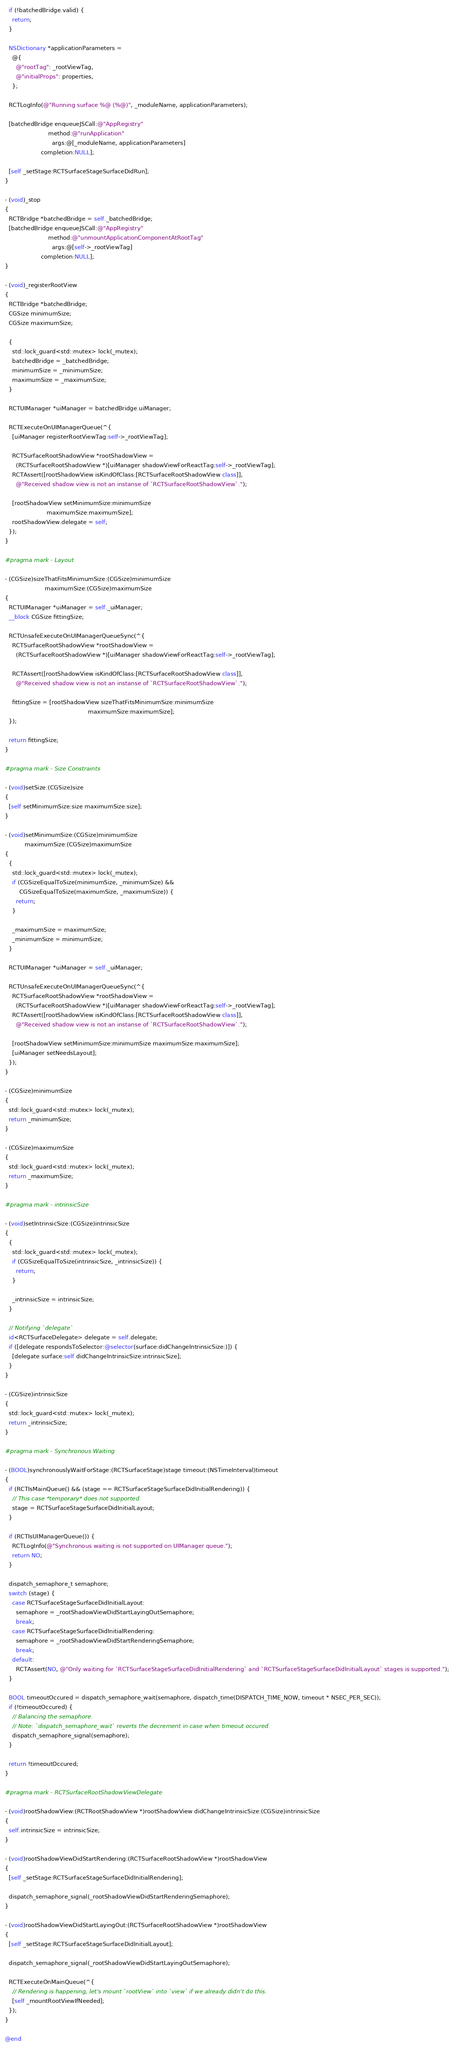<code> <loc_0><loc_0><loc_500><loc_500><_ObjectiveC_>  if (!batchedBridge.valid) {
    return;
  }

  NSDictionary *applicationParameters =
    @{
      @"rootTag": _rootViewTag,
      @"initialProps": properties,
    };

  RCTLogInfo(@"Running surface %@ (%@)", _moduleName, applicationParameters);

  [batchedBridge enqueueJSCall:@"AppRegistry"
                        method:@"runApplication"
                          args:@[_moduleName, applicationParameters]
                    completion:NULL];

  [self _setStage:RCTSurfaceStageSurfaceDidRun];
}

- (void)_stop
{
  RCTBridge *batchedBridge = self._batchedBridge;
  [batchedBridge enqueueJSCall:@"AppRegistry"
                        method:@"unmountApplicationComponentAtRootTag"
                          args:@[self->_rootViewTag]
                    completion:NULL];
}

- (void)_registerRootView
{
  RCTBridge *batchedBridge;
  CGSize minimumSize;
  CGSize maximumSize;

  {
    std::lock_guard<std::mutex> lock(_mutex);
    batchedBridge = _batchedBridge;
    minimumSize = _minimumSize;
    maximumSize = _maximumSize;
  }

  RCTUIManager *uiManager = batchedBridge.uiManager;

  RCTExecuteOnUIManagerQueue(^{
    [uiManager registerRootViewTag:self->_rootViewTag];

    RCTSurfaceRootShadowView *rootShadowView =
      (RCTSurfaceRootShadowView *)[uiManager shadowViewForReactTag:self->_rootViewTag];
    RCTAssert([rootShadowView isKindOfClass:[RCTSurfaceRootShadowView class]],
      @"Received shadow view is not an instanse of `RCTSurfaceRootShadowView`.");

    [rootShadowView setMinimumSize:minimumSize
                       maximumSize:maximumSize];
    rootShadowView.delegate = self;
  });
}

#pragma mark - Layout

- (CGSize)sizeThatFitsMinimumSize:(CGSize)minimumSize
                      maximumSize:(CGSize)maximumSize
{
  RCTUIManager *uiManager = self._uiManager;
  __block CGSize fittingSize;

  RCTUnsafeExecuteOnUIManagerQueueSync(^{
    RCTSurfaceRootShadowView *rootShadowView =
      (RCTSurfaceRootShadowView *)[uiManager shadowViewForReactTag:self->_rootViewTag];

    RCTAssert([rootShadowView isKindOfClass:[RCTSurfaceRootShadowView class]],
      @"Received shadow view is not an instanse of `RCTSurfaceRootShadowView`.");

    fittingSize = [rootShadowView sizeThatFitsMinimumSize:minimumSize
                                              maximumSize:maximumSize];
  });

  return fittingSize;
}

#pragma mark - Size Constraints

- (void)setSize:(CGSize)size
{
  [self setMinimumSize:size maximumSize:size];
}

- (void)setMinimumSize:(CGSize)minimumSize
           maximumSize:(CGSize)maximumSize
{
  {
    std::lock_guard<std::mutex> lock(_mutex);
    if (CGSizeEqualToSize(minimumSize, _minimumSize) &&
        CGSizeEqualToSize(maximumSize, _maximumSize)) {
      return;
    }

    _maximumSize = maximumSize;
    _minimumSize = minimumSize;
  }

  RCTUIManager *uiManager = self._uiManager;

  RCTUnsafeExecuteOnUIManagerQueueSync(^{
    RCTSurfaceRootShadowView *rootShadowView =
      (RCTSurfaceRootShadowView *)[uiManager shadowViewForReactTag:self->_rootViewTag];
    RCTAssert([rootShadowView isKindOfClass:[RCTSurfaceRootShadowView class]],
      @"Received shadow view is not an instanse of `RCTSurfaceRootShadowView`.");

    [rootShadowView setMinimumSize:minimumSize maximumSize:maximumSize];
    [uiManager setNeedsLayout];
  });
}

- (CGSize)minimumSize
{
  std::lock_guard<std::mutex> lock(_mutex);
  return _minimumSize;
}

- (CGSize)maximumSize
{
  std::lock_guard<std::mutex> lock(_mutex);
  return _maximumSize;
}

#pragma mark - intrinsicSize

- (void)setIntrinsicSize:(CGSize)intrinsicSize
{
  {
    std::lock_guard<std::mutex> lock(_mutex);
    if (CGSizeEqualToSize(intrinsicSize, _intrinsicSize)) {
      return;
    }

    _intrinsicSize = intrinsicSize;
  }

  // Notifying `delegate`
  id<RCTSurfaceDelegate> delegate = self.delegate;
  if ([delegate respondsToSelector:@selector(surface:didChangeIntrinsicSize:)]) {
    [delegate surface:self didChangeIntrinsicSize:intrinsicSize];
  }
}

- (CGSize)intrinsicSize
{
  std::lock_guard<std::mutex> lock(_mutex);
  return _intrinsicSize;
}

#pragma mark - Synchronous Waiting

- (BOOL)synchronouslyWaitForStage:(RCTSurfaceStage)stage timeout:(NSTimeInterval)timeout
{
  if (RCTIsMainQueue() && (stage == RCTSurfaceStageSurfaceDidInitialRendering)) {
    // This case *temporary* does not supported.
    stage = RCTSurfaceStageSurfaceDidInitialLayout;
  }

  if (RCTIsUIManagerQueue()) {
    RCTLogInfo(@"Synchronous waiting is not supported on UIManager queue.");
    return NO;
  }

  dispatch_semaphore_t semaphore;
  switch (stage) {
    case RCTSurfaceStageSurfaceDidInitialLayout:
      semaphore = _rootShadowViewDidStartLayingOutSemaphore;
      break;
    case RCTSurfaceStageSurfaceDidInitialRendering:
      semaphore = _rootShadowViewDidStartRenderingSemaphore;
      break;
    default:
      RCTAssert(NO, @"Only waiting for `RCTSurfaceStageSurfaceDidInitialRendering` and `RCTSurfaceStageSurfaceDidInitialLayout` stages is supported.");
  }

  BOOL timeoutOccured = dispatch_semaphore_wait(semaphore, dispatch_time(DISPATCH_TIME_NOW, timeout * NSEC_PER_SEC));
  if (!timeoutOccured) {
    // Balancing the semaphore.
    // Note: `dispatch_semaphore_wait` reverts the decrement in case when timeout occured.
    dispatch_semaphore_signal(semaphore);
  }

  return !timeoutOccured;
}

#pragma mark - RCTSurfaceRootShadowViewDelegate

- (void)rootShadowView:(RCTRootShadowView *)rootShadowView didChangeIntrinsicSize:(CGSize)intrinsicSize
{
  self.intrinsicSize = intrinsicSize;
}

- (void)rootShadowViewDidStartRendering:(RCTSurfaceRootShadowView *)rootShadowView
{
  [self _setStage:RCTSurfaceStageSurfaceDidInitialRendering];

  dispatch_semaphore_signal(_rootShadowViewDidStartRenderingSemaphore);
}

- (void)rootShadowViewDidStartLayingOut:(RCTSurfaceRootShadowView *)rootShadowView
{
  [self _setStage:RCTSurfaceStageSurfaceDidInitialLayout];

  dispatch_semaphore_signal(_rootShadowViewDidStartLayingOutSemaphore);

  RCTExecuteOnMainQueue(^{
    // Rendering is happening, let's mount `rootView` into `view` if we already didn't do this.
    [self _mountRootViewIfNeeded];
  });
}

@end
</code> 